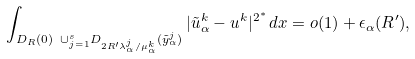Convert formula to latex. <formula><loc_0><loc_0><loc_500><loc_500>\int _ { D _ { R } ( 0 ) \ \cup ^ { s } _ { j = 1 } D _ { 2 R ^ { \prime } \lambda ^ { j } _ { \alpha } / \mu ^ { k } _ { \alpha } } ( \tilde { y } ^ { j } _ { \alpha } ) } | \tilde { u } ^ { k } _ { \alpha } - u ^ { k } | ^ { 2 ^ { * } } \, d x = o ( 1 ) + \epsilon _ { \alpha } ( R ^ { \prime } ) ,</formula> 